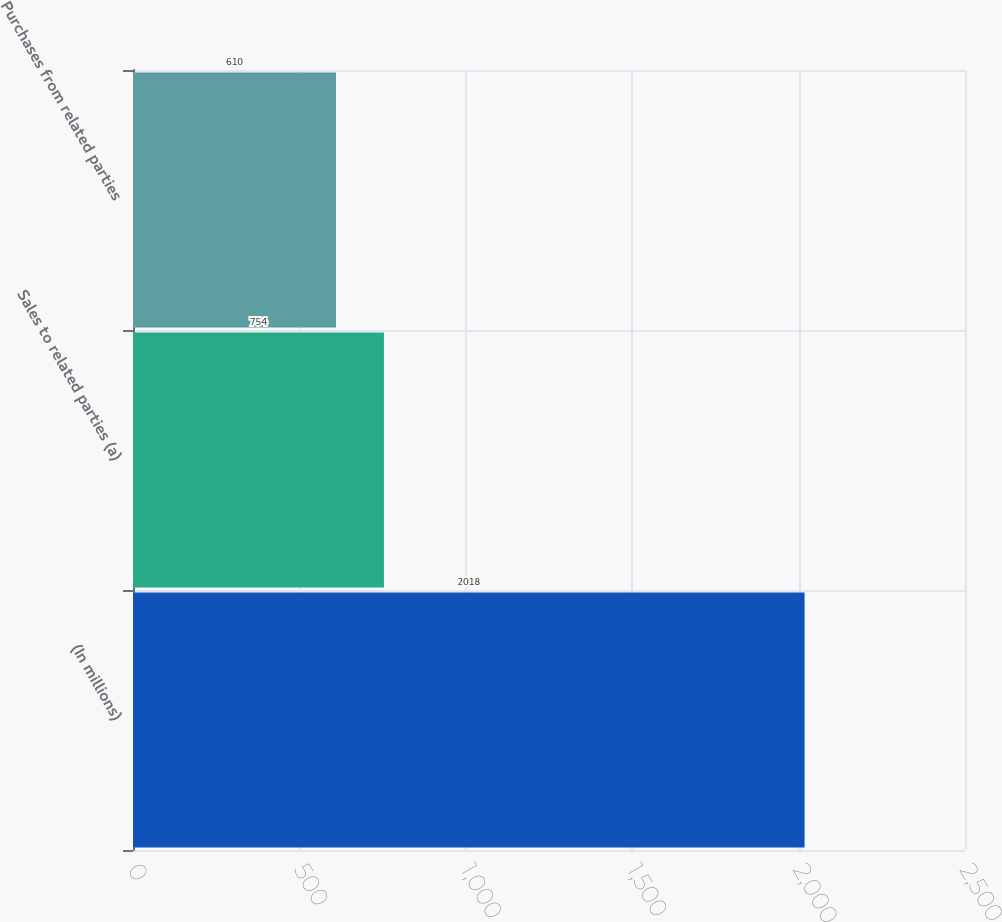Convert chart to OTSL. <chart><loc_0><loc_0><loc_500><loc_500><bar_chart><fcel>(In millions)<fcel>Sales to related parties (a)<fcel>Purchases from related parties<nl><fcel>2018<fcel>754<fcel>610<nl></chart> 